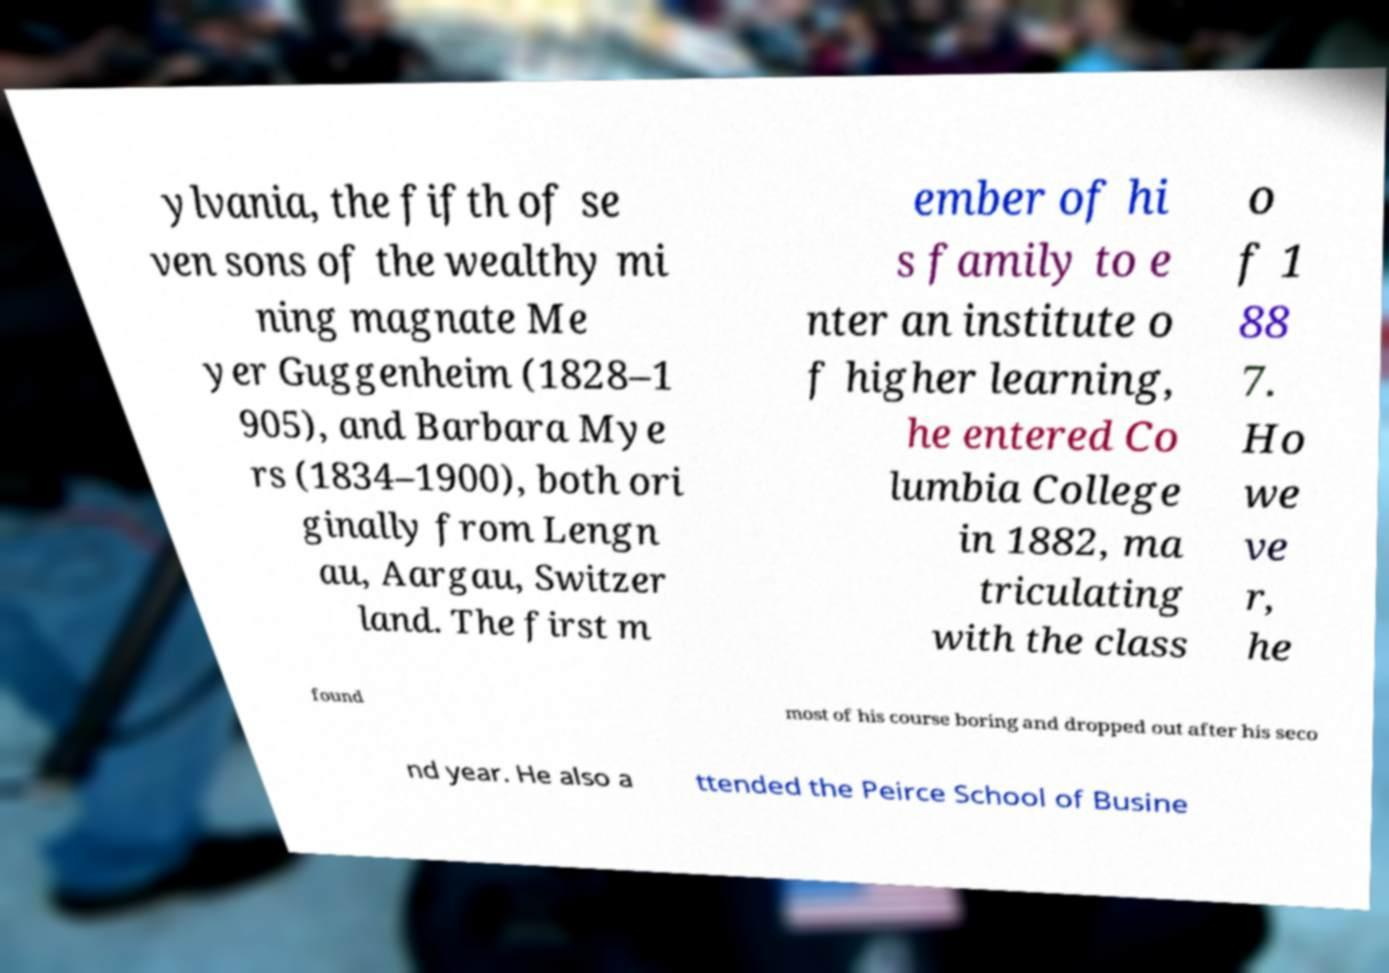Can you read and provide the text displayed in the image?This photo seems to have some interesting text. Can you extract and type it out for me? ylvania, the fifth of se ven sons of the wealthy mi ning magnate Me yer Guggenheim (1828–1 905), and Barbara Mye rs (1834–1900), both ori ginally from Lengn au, Aargau, Switzer land. The first m ember of hi s family to e nter an institute o f higher learning, he entered Co lumbia College in 1882, ma triculating with the class o f 1 88 7. Ho we ve r, he found most of his course boring and dropped out after his seco nd year. He also a ttended the Peirce School of Busine 